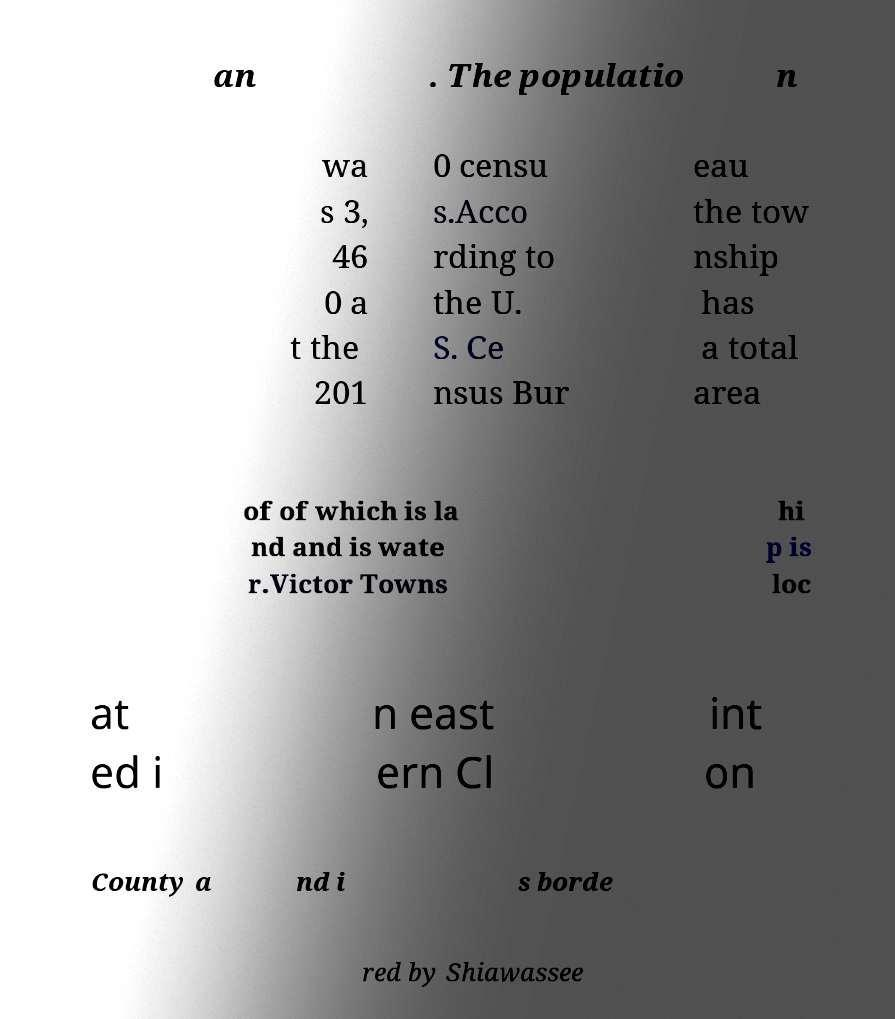There's text embedded in this image that I need extracted. Can you transcribe it verbatim? an . The populatio n wa s 3, 46 0 a t the 201 0 censu s.Acco rding to the U. S. Ce nsus Bur eau the tow nship has a total area of of which is la nd and is wate r.Victor Towns hi p is loc at ed i n east ern Cl int on County a nd i s borde red by Shiawassee 